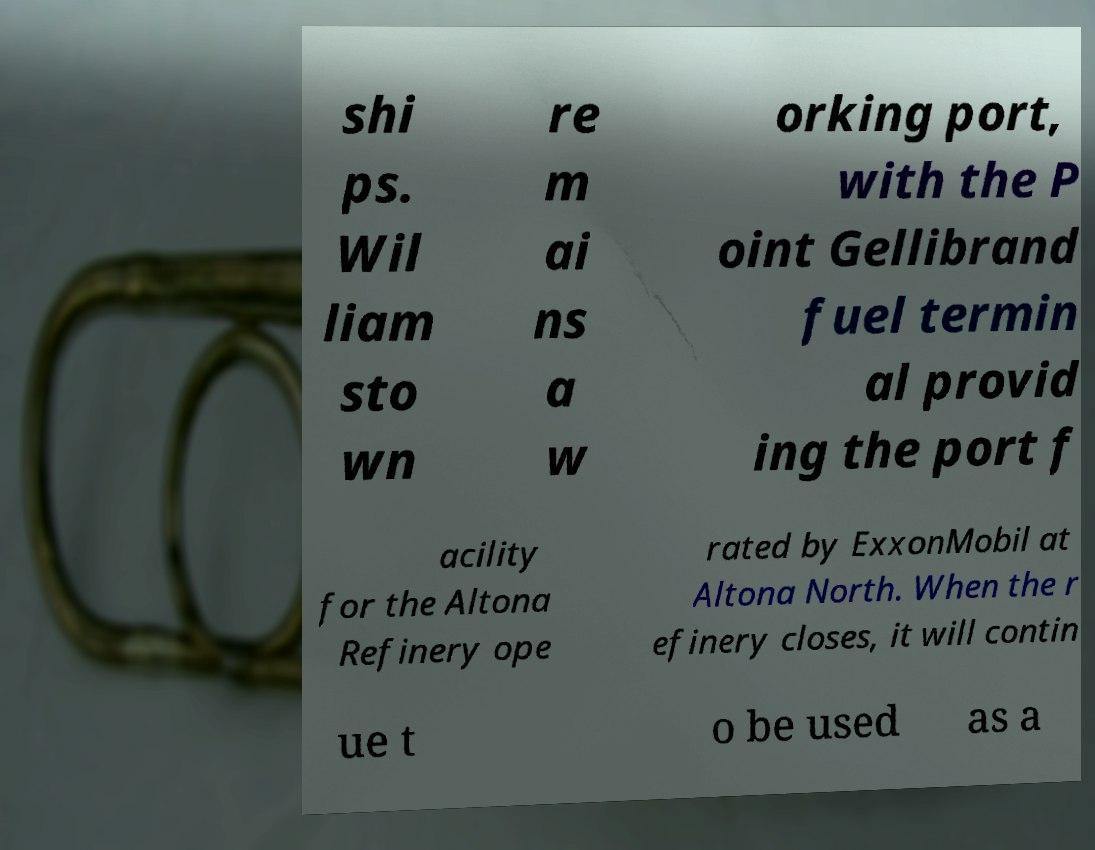Could you extract and type out the text from this image? shi ps. Wil liam sto wn re m ai ns a w orking port, with the P oint Gellibrand fuel termin al provid ing the port f acility for the Altona Refinery ope rated by ExxonMobil at Altona North. When the r efinery closes, it will contin ue t o be used as a 